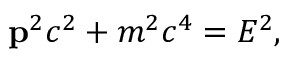Convert formula to latex. <formula><loc_0><loc_0><loc_500><loc_500>p ^ { 2 } c ^ { 2 } + m ^ { 2 } c ^ { 4 } = E ^ { 2 } ,</formula> 